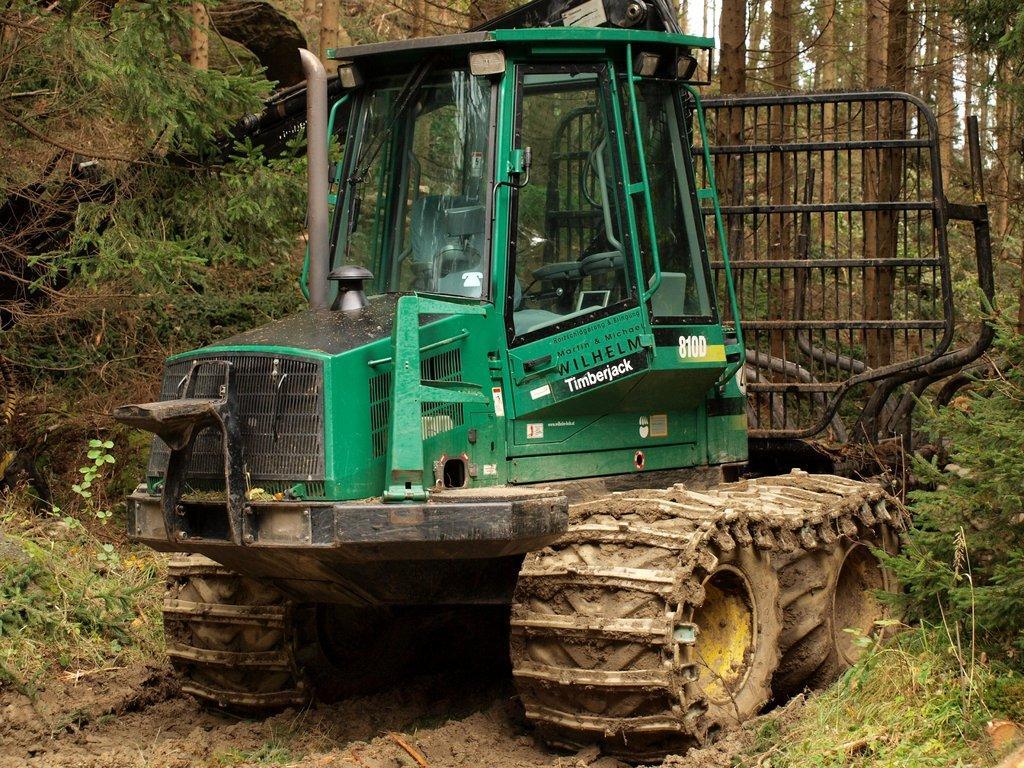Can you describe this image briefly? In this picture there is a tractor in the center of the image and there are trees on the right and left side of the image. 